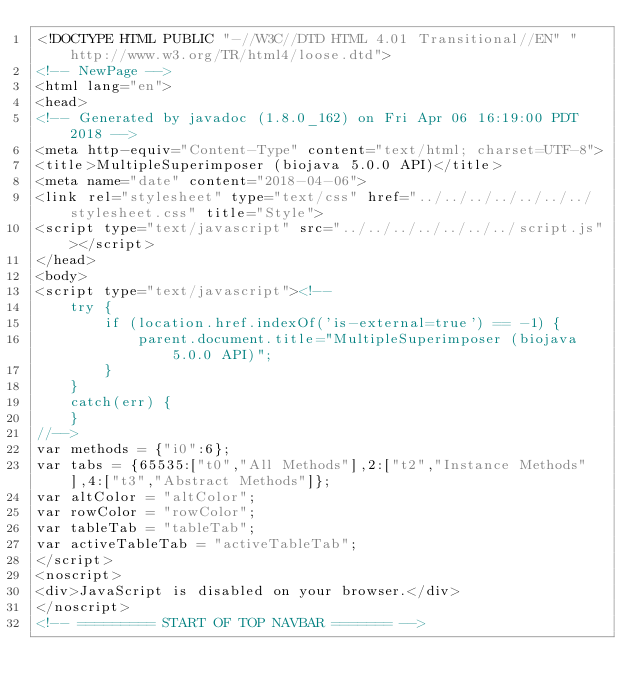<code> <loc_0><loc_0><loc_500><loc_500><_HTML_><!DOCTYPE HTML PUBLIC "-//W3C//DTD HTML 4.01 Transitional//EN" "http://www.w3.org/TR/html4/loose.dtd">
<!-- NewPage -->
<html lang="en">
<head>
<!-- Generated by javadoc (1.8.0_162) on Fri Apr 06 16:19:00 PDT 2018 -->
<meta http-equiv="Content-Type" content="text/html; charset=UTF-8">
<title>MultipleSuperimposer (biojava 5.0.0 API)</title>
<meta name="date" content="2018-04-06">
<link rel="stylesheet" type="text/css" href="../../../../../../../stylesheet.css" title="Style">
<script type="text/javascript" src="../../../../../../../script.js"></script>
</head>
<body>
<script type="text/javascript"><!--
    try {
        if (location.href.indexOf('is-external=true') == -1) {
            parent.document.title="MultipleSuperimposer (biojava 5.0.0 API)";
        }
    }
    catch(err) {
    }
//-->
var methods = {"i0":6};
var tabs = {65535:["t0","All Methods"],2:["t2","Instance Methods"],4:["t3","Abstract Methods"]};
var altColor = "altColor";
var rowColor = "rowColor";
var tableTab = "tableTab";
var activeTableTab = "activeTableTab";
</script>
<noscript>
<div>JavaScript is disabled on your browser.</div>
</noscript>
<!-- ========= START OF TOP NAVBAR ======= --></code> 